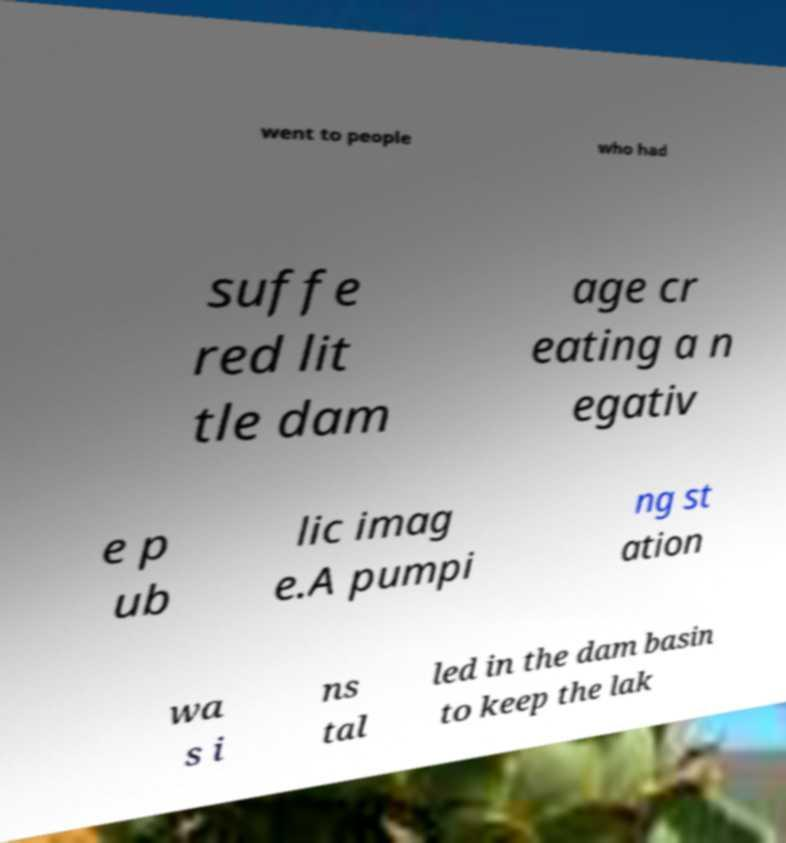Please read and relay the text visible in this image. What does it say? went to people who had suffe red lit tle dam age cr eating a n egativ e p ub lic imag e.A pumpi ng st ation wa s i ns tal led in the dam basin to keep the lak 